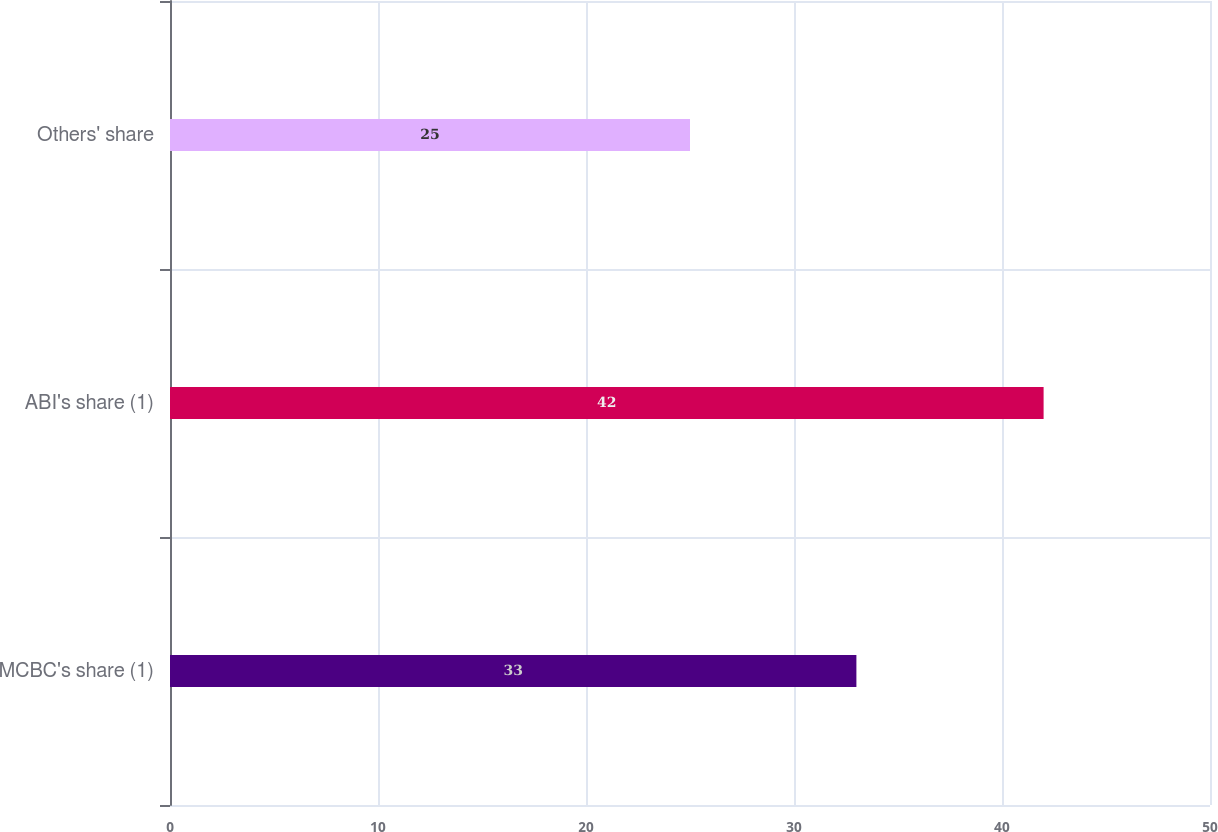Convert chart to OTSL. <chart><loc_0><loc_0><loc_500><loc_500><bar_chart><fcel>MCBC's share (1)<fcel>ABI's share (1)<fcel>Others' share<nl><fcel>33<fcel>42<fcel>25<nl></chart> 